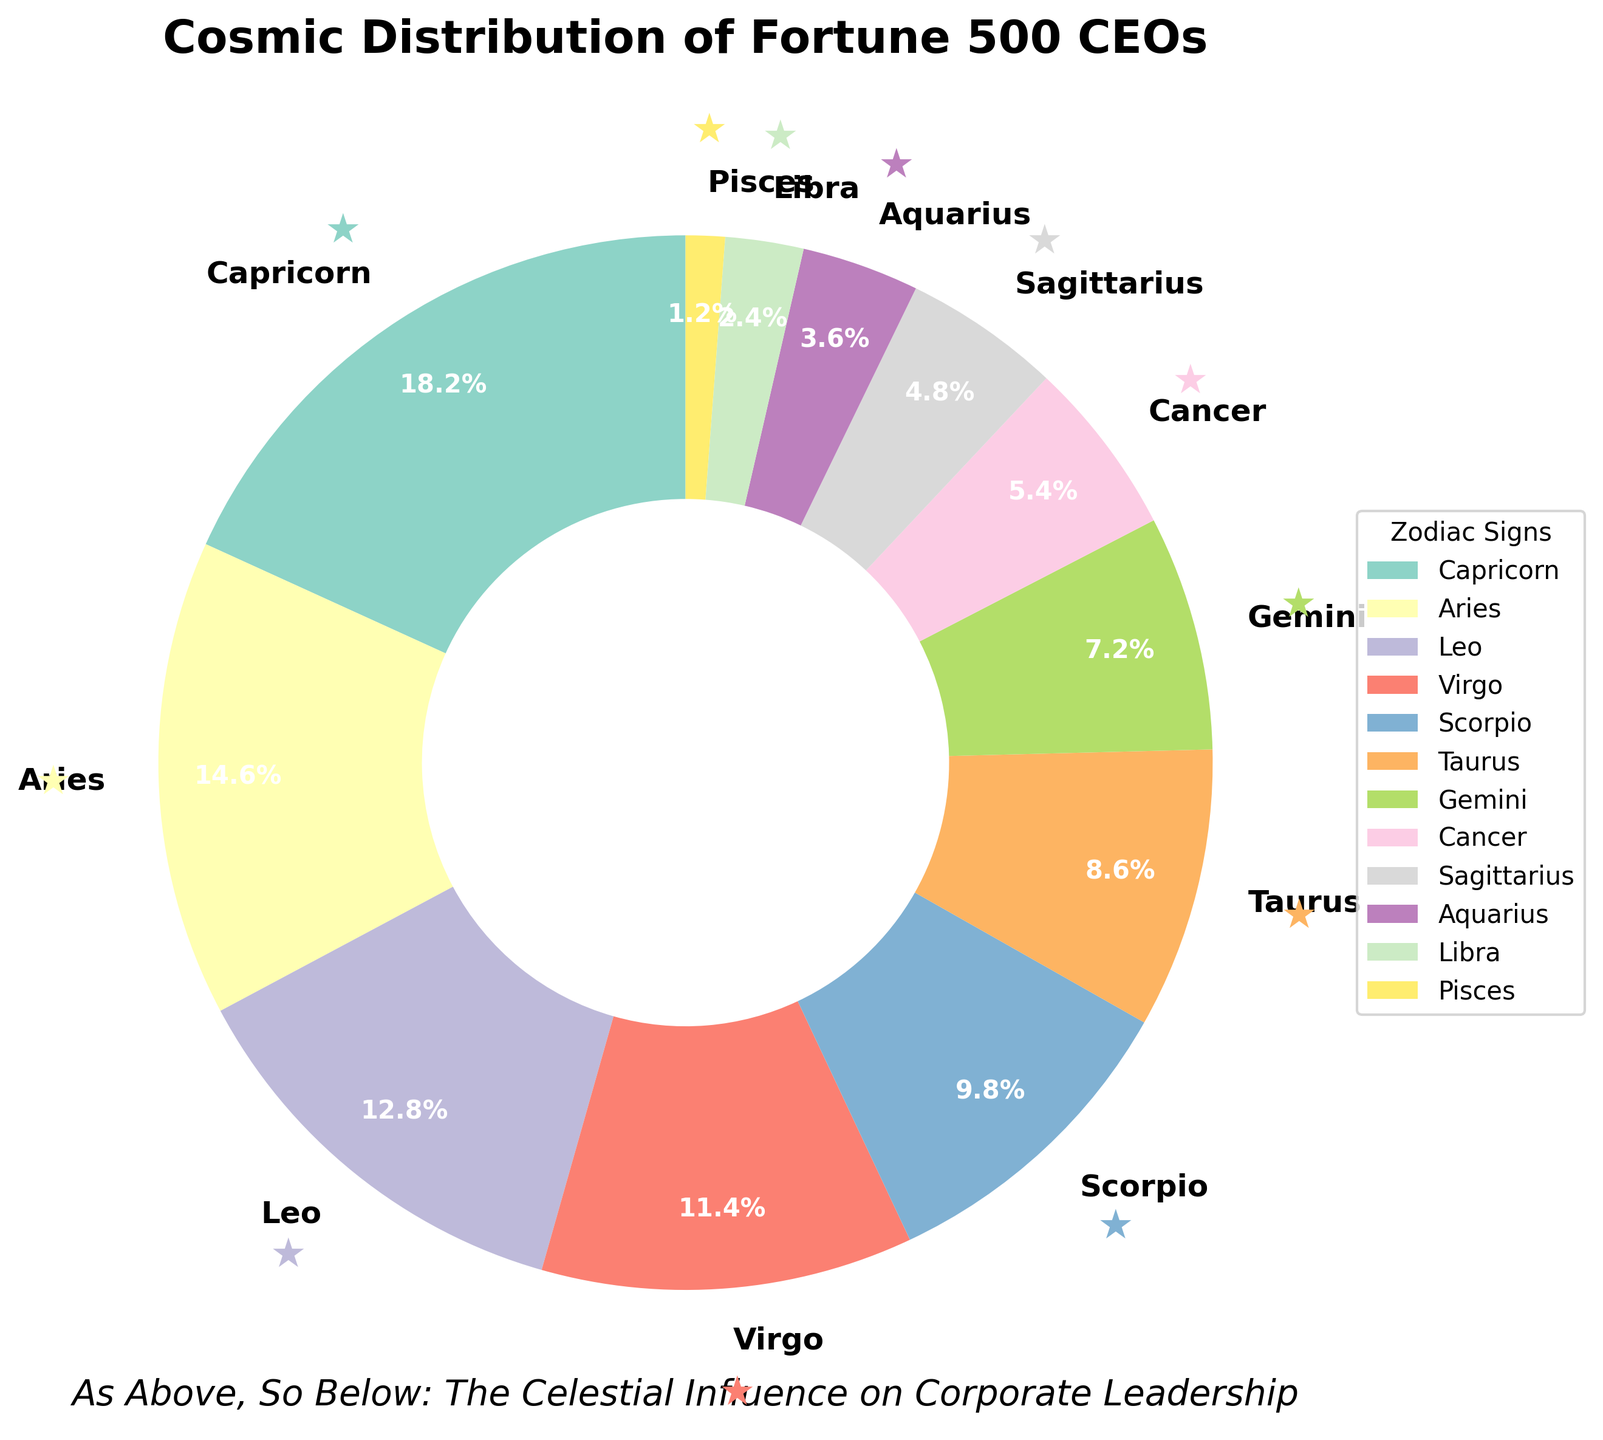Which zodiac sign has the largest representation among Fortune 500 CEOs? The largest segment in the pie chart represents the zodiac sign with the highest percentage. According to the figure, Capricorn occupies the largest section.
Answer: Capricorn What is the combined percentage of CEOs with the signs Aries and Taurus? Add the percentages of Aries and Taurus together. From the chart, Aries is 14.6% and Taurus is 8.6%. So, 14.6% + 8.6% = 23.2%.
Answer: 23.2% Which zodiac sign has a smaller representation than Gemini but larger than Cancer? Identify the segments labeled for Gemini and Cancer in the chart and look for the one in between them. Gemini is at 7.2% and Cancer at 5.4%. The sign in between them is Taurus with 8.6%.
Answer: Taurus How many zodiac signs have a representation of less than 5% among CEOs? Count the segments in the pie chart that represent less than 5%. These include Sagittarius (4.8%), Aquarius (3.6%), Libra (2.4%), and Pisces (1.2%). This gives a total of 4 zodiac signs.
Answer: 4 Which sign has a darker color wedge than Virgo in the chart? Look at the pie chart and compare the color used for Virgo's wedge with other wedges. The sign Leo, which is depicted darker in the color gradient used, is darker than Virgo.
Answer: Leo What is the percentage difference between Capricorn and Leo? Subtract the percentage of Leo from the percentage of Capricorn. Capricorn is 18.2% and Leo is 12.8%. Thus, 18.2% - 12.8% = 5.4%.
Answer: 5.4% List the three least common zodiac signs among Fortune 500 CEOs. Examine the chart for the three smallest wedges. These are Pisces (1.2%), Libra (2.4%), and Aquarius (3.6%).
Answer: Pisces, Libra, Aquarius Which zodiac signs represent more than 10% but less than 15% of the CEOs? Identify the segments that fall within this range. Aries (14.6%) and Leo (12.8%) both meet these criteria.
Answer: Aries, Leo What is the total percentage of CEOs whose zodiac signs fall under water signs (Cancer, Scorpio, Pisces)? Add the percentages of Cancer, Scorpio, and Pisces. Cancer is 5.4%, Scorpio is 9.8%, and Pisces is 1.2%. So, 5.4% + 9.8% + 1.2% = 16.4%.
Answer: 16.4% In terms of color distribution, which zodiac sign is represented by the lightest color wedge in the chart? Compare all the wedges and identify the one with the lightest shade. The sign represented by the lightest color is Pisces.
Answer: Pisces 